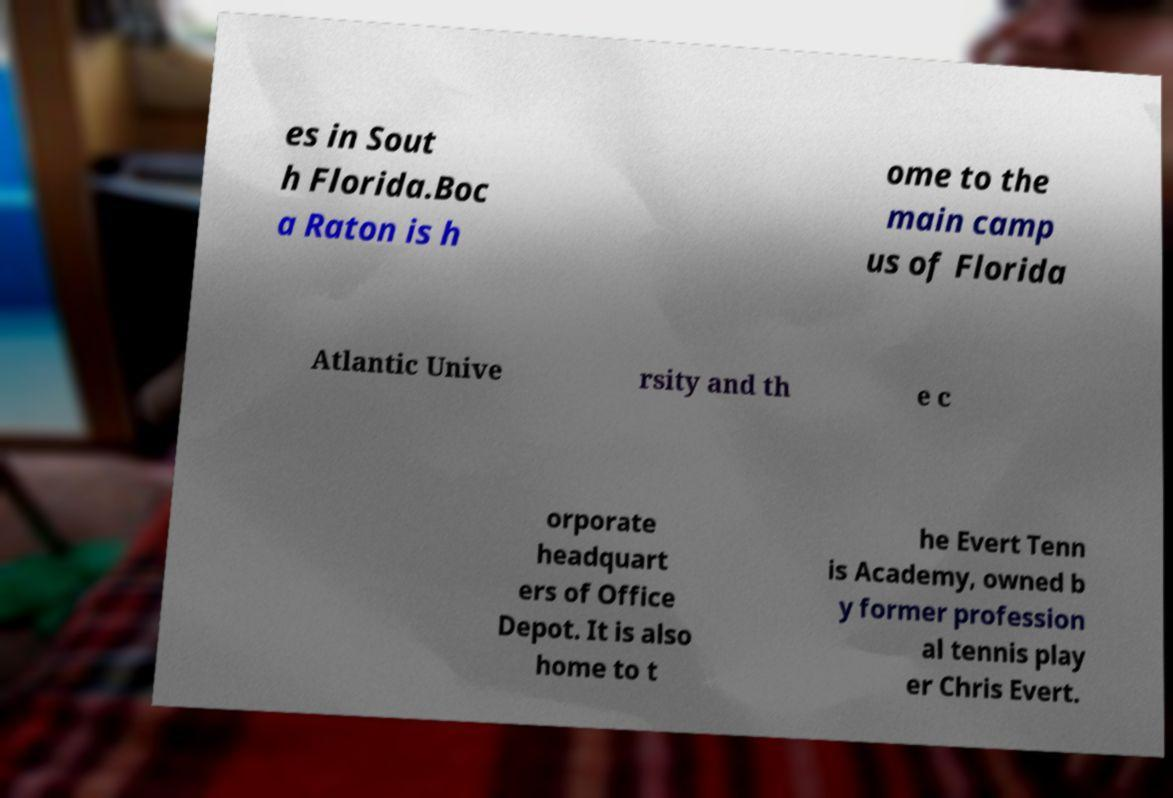For documentation purposes, I need the text within this image transcribed. Could you provide that? es in Sout h Florida.Boc a Raton is h ome to the main camp us of Florida Atlantic Unive rsity and th e c orporate headquart ers of Office Depot. It is also home to t he Evert Tenn is Academy, owned b y former profession al tennis play er Chris Evert. 